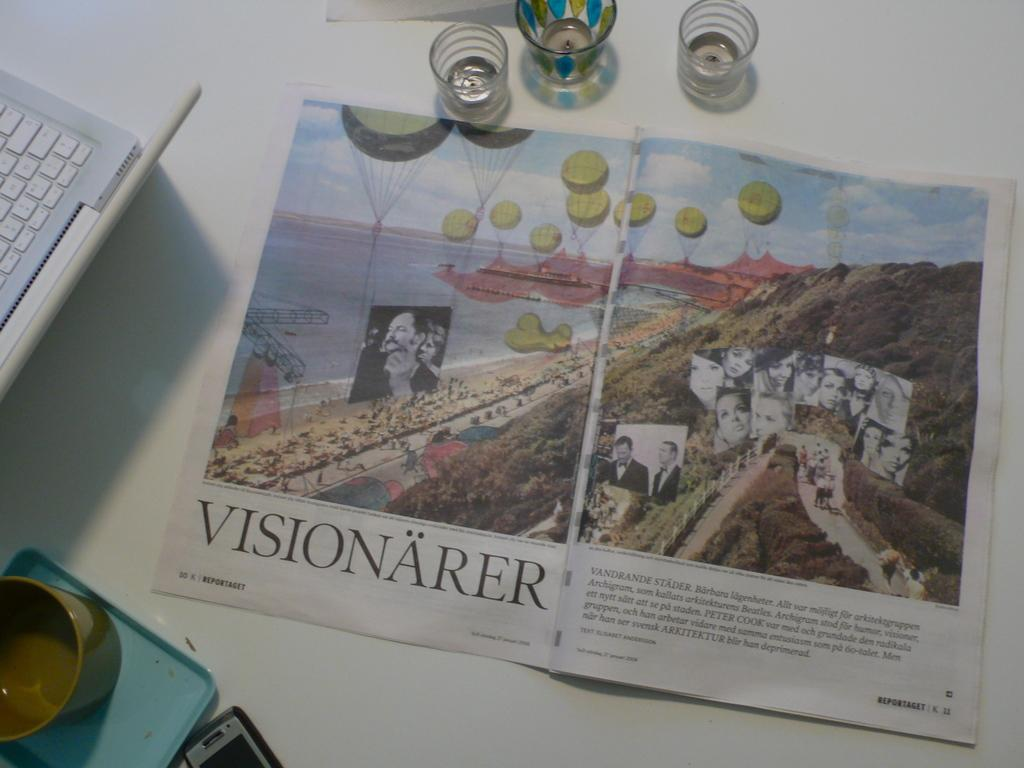<image>
Summarize the visual content of the image. A magazine sits on a white desk and is open to a page that reads, "Visionärer". 